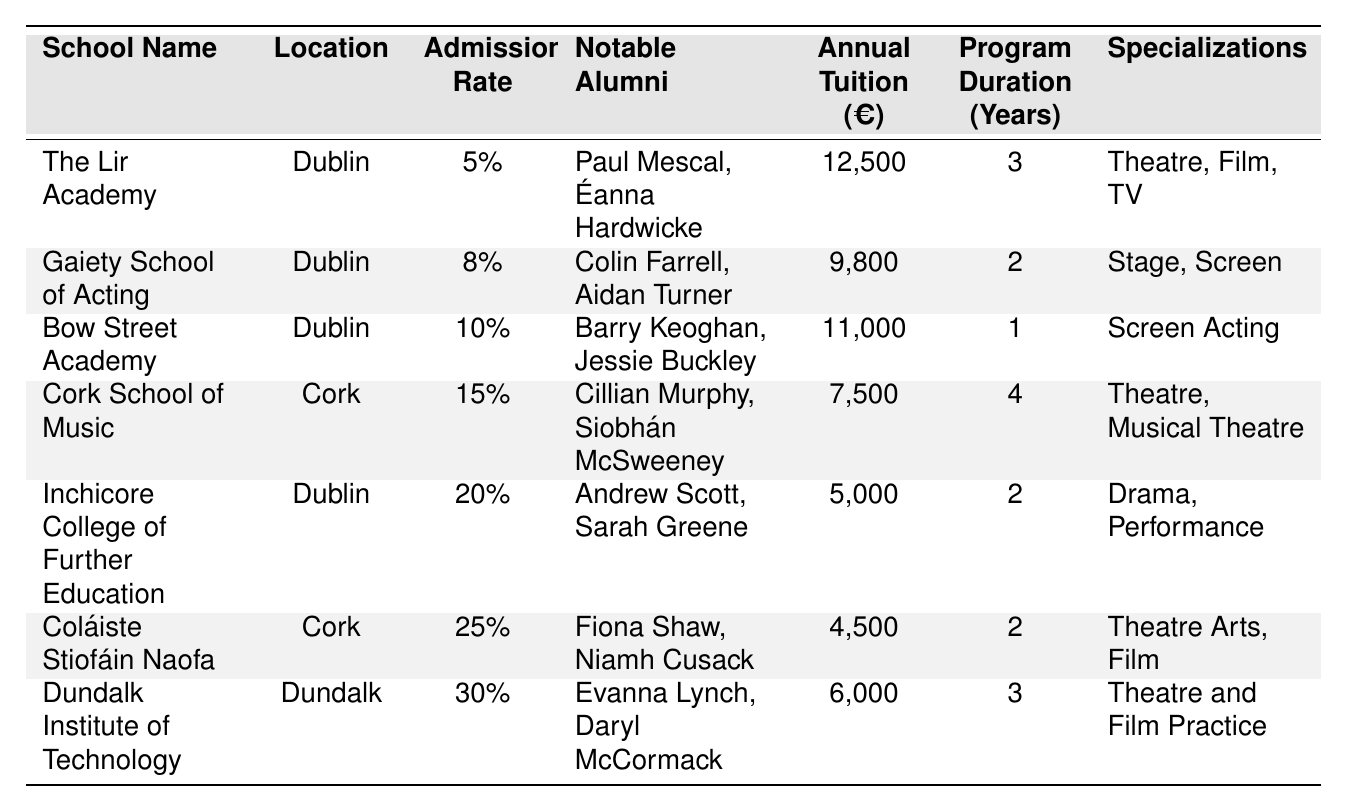What is the admission rate of The Lir Academy? The admission rate of The Lir Academy is explicitly listed in the table as 5%.
Answer: 5% Which school located in Cork has the highest admission rate? By comparing the admission rates of the schools in Cork, Coláiste Stiofáin Naofa has an admission rate of 25%, which is higher than the Cork School of Music’s 15%.
Answer: Coláiste Stiofáin Naofa Who are the notable alumni of Bow Street Academy? The notable alumni of Bow Street Academy, as listed in the table, are Barry Keoghan and Jessie Buckley.
Answer: Barry Keoghan, Jessie Buckley What is the annual tuition fee for the Gaiety School of Acting? The annual tuition fee for the Gaiety School of Acting is mentioned in the table as €9,800.
Answer: €9,800 What is the total annual tuition for all schools listed in the table? The total annual tuition is calculated by adding the tuition fees of each school: 12500 + 9800 + 11000 + 7500 + 5000 + 4500 + 6000 = 26100.
Answer: €26,100 Does the Cork School of Music have any notable alumni who are also graduates from The Lir Academy? The notable alumni of The Cork School of Music do not overlap with those of The Lir Academy based on the table, so the answer is no.
Answer: No Which school has the longest program duration, and how many years is it? The Cork School of Music has the longest program duration of 4 years, which can be identified by comparing the program durations of each school listed in the table.
Answer: Cork School of Music, 4 years What is the average admission rate of the schools located in Dublin? Calculate the average admission rate by adding the rates of the Dublin schools (5% + 8% + 10% + 20%) = 43%, then divide by the number of schools (4): 43% / 4 = 10.75%.
Answer: 10.75% Which notable alumni graduated from schools with an admission rate lower than 15%? The notable alumni from schools with an admission rate lower than 15% are Paul Mescal, Éanna Hardwicke (The Lir Academy) and Colin Farrell, Aidan Turner (Gaiety School of Acting).
Answer: Paul Mescal, Éanna Hardwicke, Colin Farrell, Aidan Turner If you combine the specializations offered at The Lir Academy and Cork School of Music, how many unique specializations are there? The specializations at The Lir Academy are Theatre, Film, and TV, while Cork School of Music offers Theatre and Musical Theatre. Combining these, we have unique specializations of Theatre, Film, TV, and Musical Theatre, totaling 4 unique specializations.
Answer: 4 unique specializations 